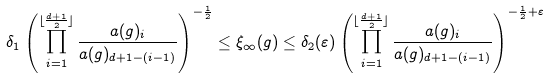<formula> <loc_0><loc_0><loc_500><loc_500>\delta _ { 1 } \left ( \prod _ { i = 1 } ^ { \lfloor \frac { d + 1 } { 2 } \rfloor } \frac { a ( g ) _ { i } } { a ( g ) _ { d + 1 - ( i - 1 ) } } \right ) ^ { - \frac { 1 } { 2 } } \leq \xi _ { \infty } ( g ) \leq \delta _ { 2 } ( \varepsilon ) \left ( \prod _ { i = 1 } ^ { \lfloor \frac { d + 1 } { 2 } \rfloor } \frac { a ( g ) _ { i } } { a ( g ) _ { d + 1 - ( i - 1 ) } } \right ) ^ { - \frac { 1 } { 2 } + \varepsilon }</formula> 